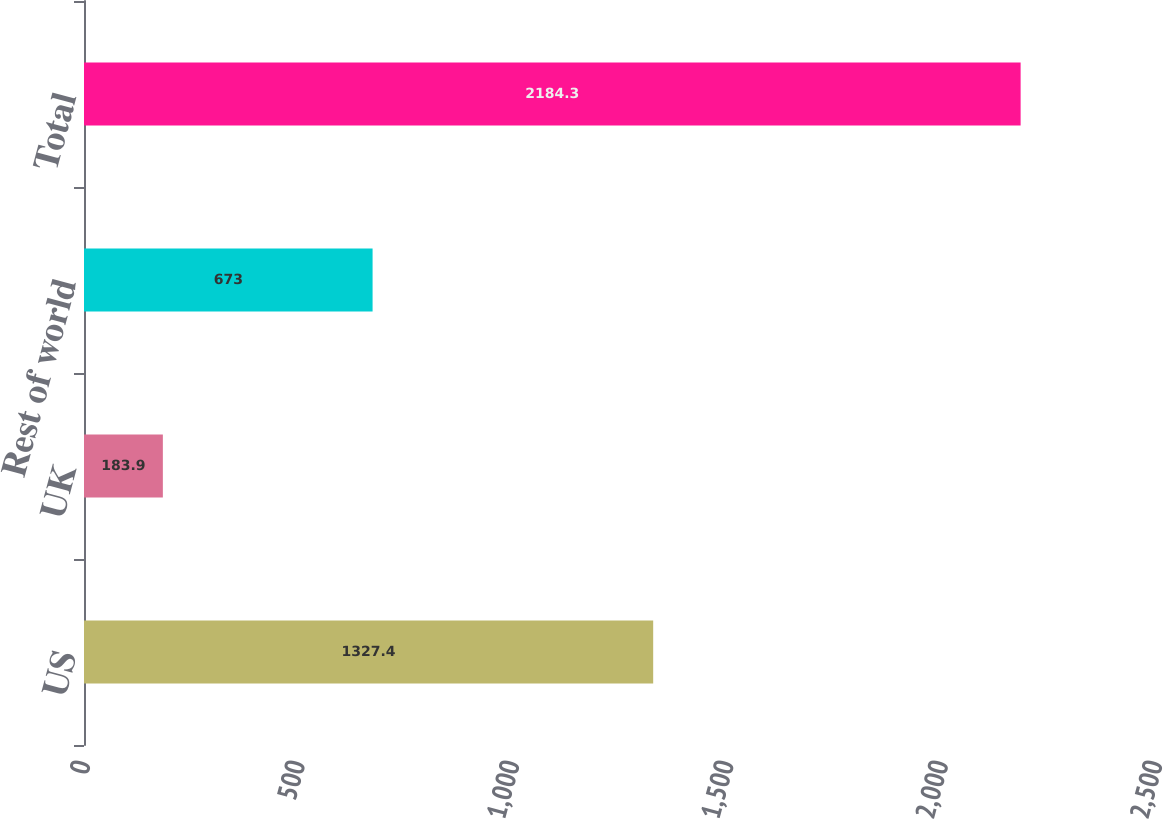Convert chart to OTSL. <chart><loc_0><loc_0><loc_500><loc_500><bar_chart><fcel>US<fcel>UK<fcel>Rest of world<fcel>Total<nl><fcel>1327.4<fcel>183.9<fcel>673<fcel>2184.3<nl></chart> 